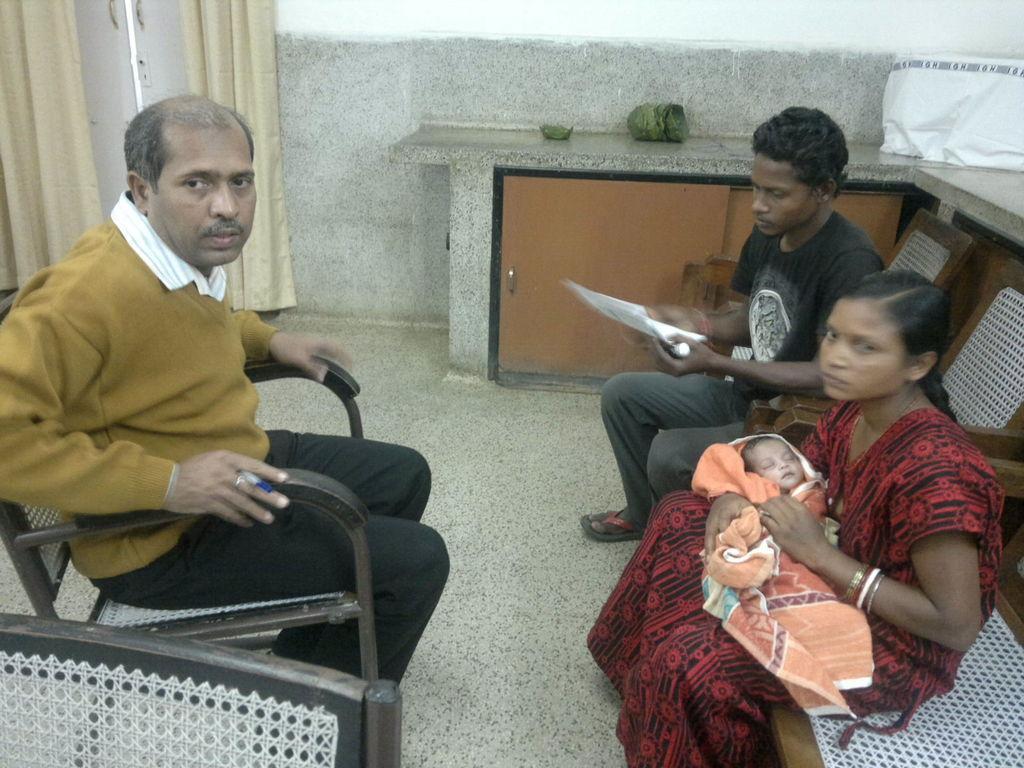Could you give a brief overview of what you see in this image? A man holding a pen is sitting on a chair. On the right side a woman holding a baby and a man holding a paper is sitting on a chair. In the background there is a wall, curtains and door. Also there is a table with cupboard. On the table there is a cover. 